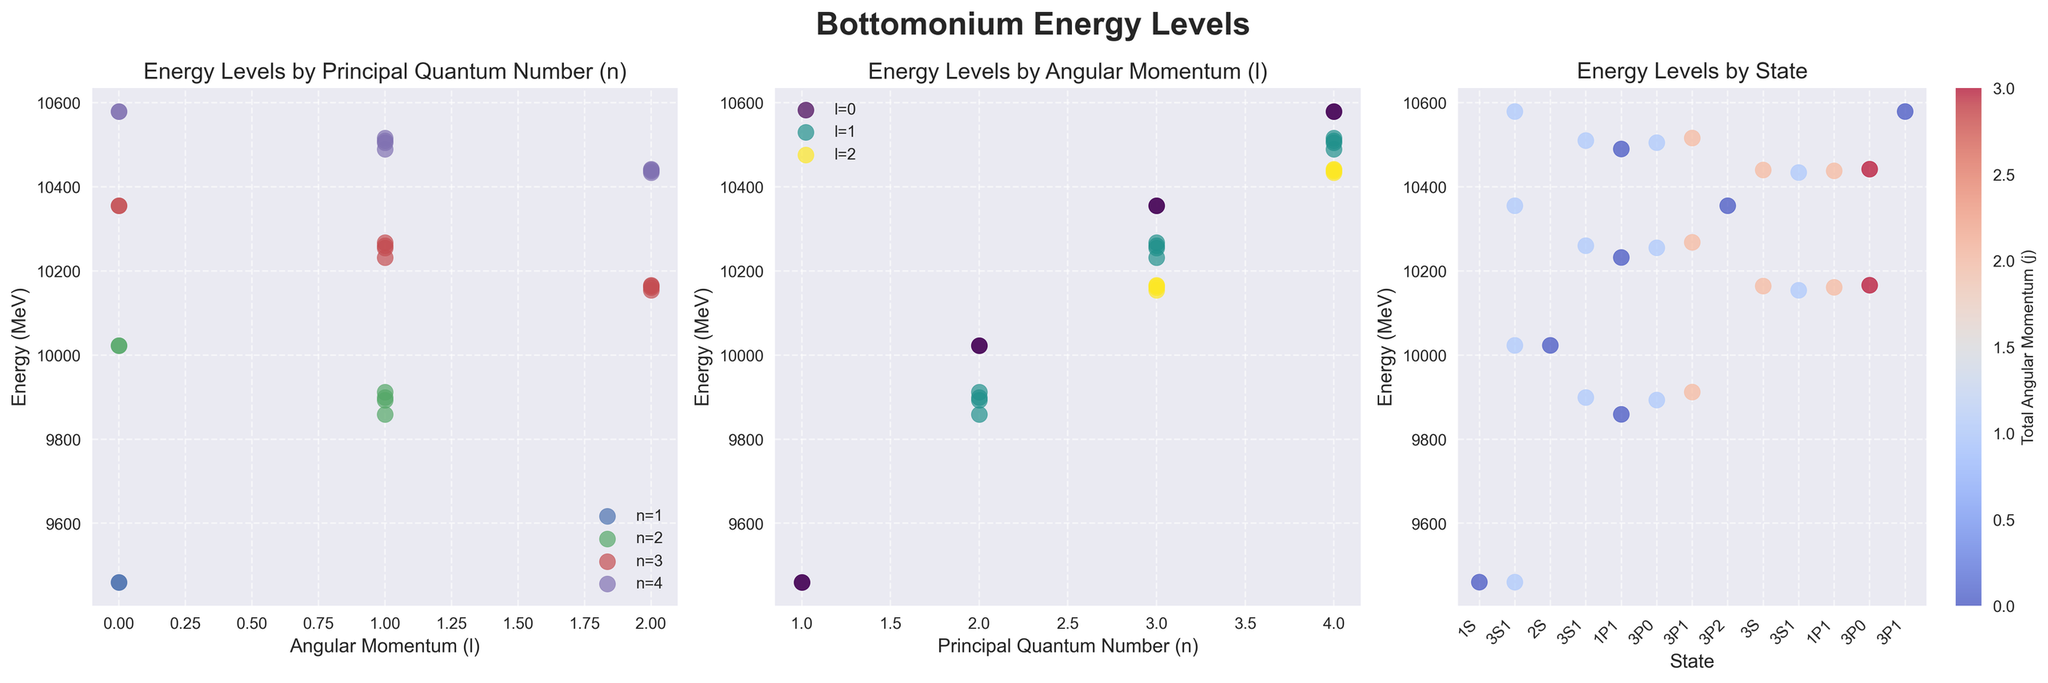What is the energy level of the state with the highest total angular momentum (j)? The state with the highest total angular momentum j=3 is the 3D3 state. According to the plot, its energy level is higher than other states with j=3. The energy level of the 3D3 state is 10166 MeV.
Answer: 10166 MeV Which principal quantum number n has the highest average energy level? To find the highest average energy level, we calculate the average energy for each n-value. Comparing the averages, n=4 has the highest average energy level.
Answer: n=4 How many states have an angular momentum l=2? By examining the plot for the second subplot (Energy Levels by Angular Momentum), we see there are multiple points aligned with l=2. Counting those points, we find there are six states with angular momentum l=2.
Answer: 6 What is the difference in energy between the states 2S and 3S? From the plot, we can see the energy levels for states 2S and 3S are 10023 MeV and 10355 MeV respectively. The difference is calculated as 10355 - 10023 = 332 MeV.
Answer: 332 MeV Which state has the lowest energy level, and what is its value? From the third subplot (Energy Levels by State), the lowest energy level is evident for the state 3P0. The energy value of this state is 9859 MeV.
Answer: 9859 MeV Which states have the same energy level of 9460 MeV? By inspecting the third subplot, two states align at the 9460 MeV energy level. These states are 1S and 3S1.
Answer: 1S and 3S1 What is the total angular momentum (j) for the state with the highest energy level? Referring to the third subplot, the state with the highest energy level is the 4S state. The corresponding total angular momentum (j) can be inferred as 0 for 4S.
Answer: 0 Which angular momentum value l has the highest variation in energy levels? By examining the second subplot, we can see that l=2 has the highest spread of energy levels, indicating the highest variation. The range of energies for l=2 spans from around 10154 MeV to 10442 MeV.
Answer: l=2 